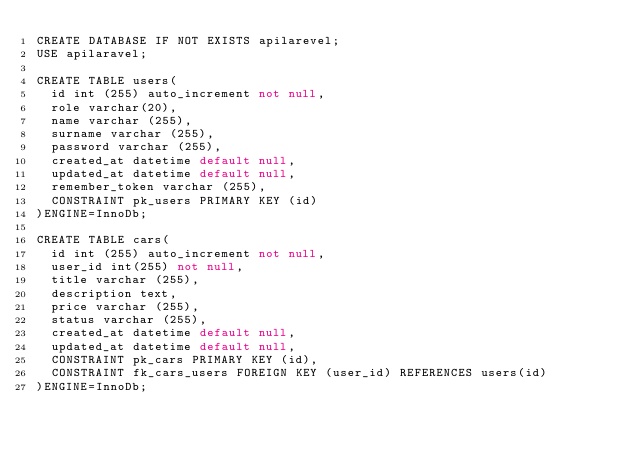<code> <loc_0><loc_0><loc_500><loc_500><_SQL_>CREATE DATABASE IF NOT EXISTS apilarevel;
USE apilaravel;

CREATE TABLE users(
  id int (255) auto_increment not null,
  role varchar(20),
  name varchar (255),
  surname varchar (255),
  password varchar (255),
  created_at datetime default null,
  updated_at datetime default null,
  remember_token varchar (255),
  CONSTRAINT pk_users PRIMARY KEY (id)
)ENGINE=InnoDb;

CREATE TABLE cars(
  id int (255) auto_increment not null,
  user_id int(255) not null,
  title varchar (255),
  description text,
  price varchar (255),
  status varchar (255),
  created_at datetime default null,
  updated_at datetime default null,
  CONSTRAINT pk_cars PRIMARY KEY (id),
  CONSTRAINT fk_cars_users FOREIGN KEY (user_id) REFERENCES users(id)
)ENGINE=InnoDb;</code> 